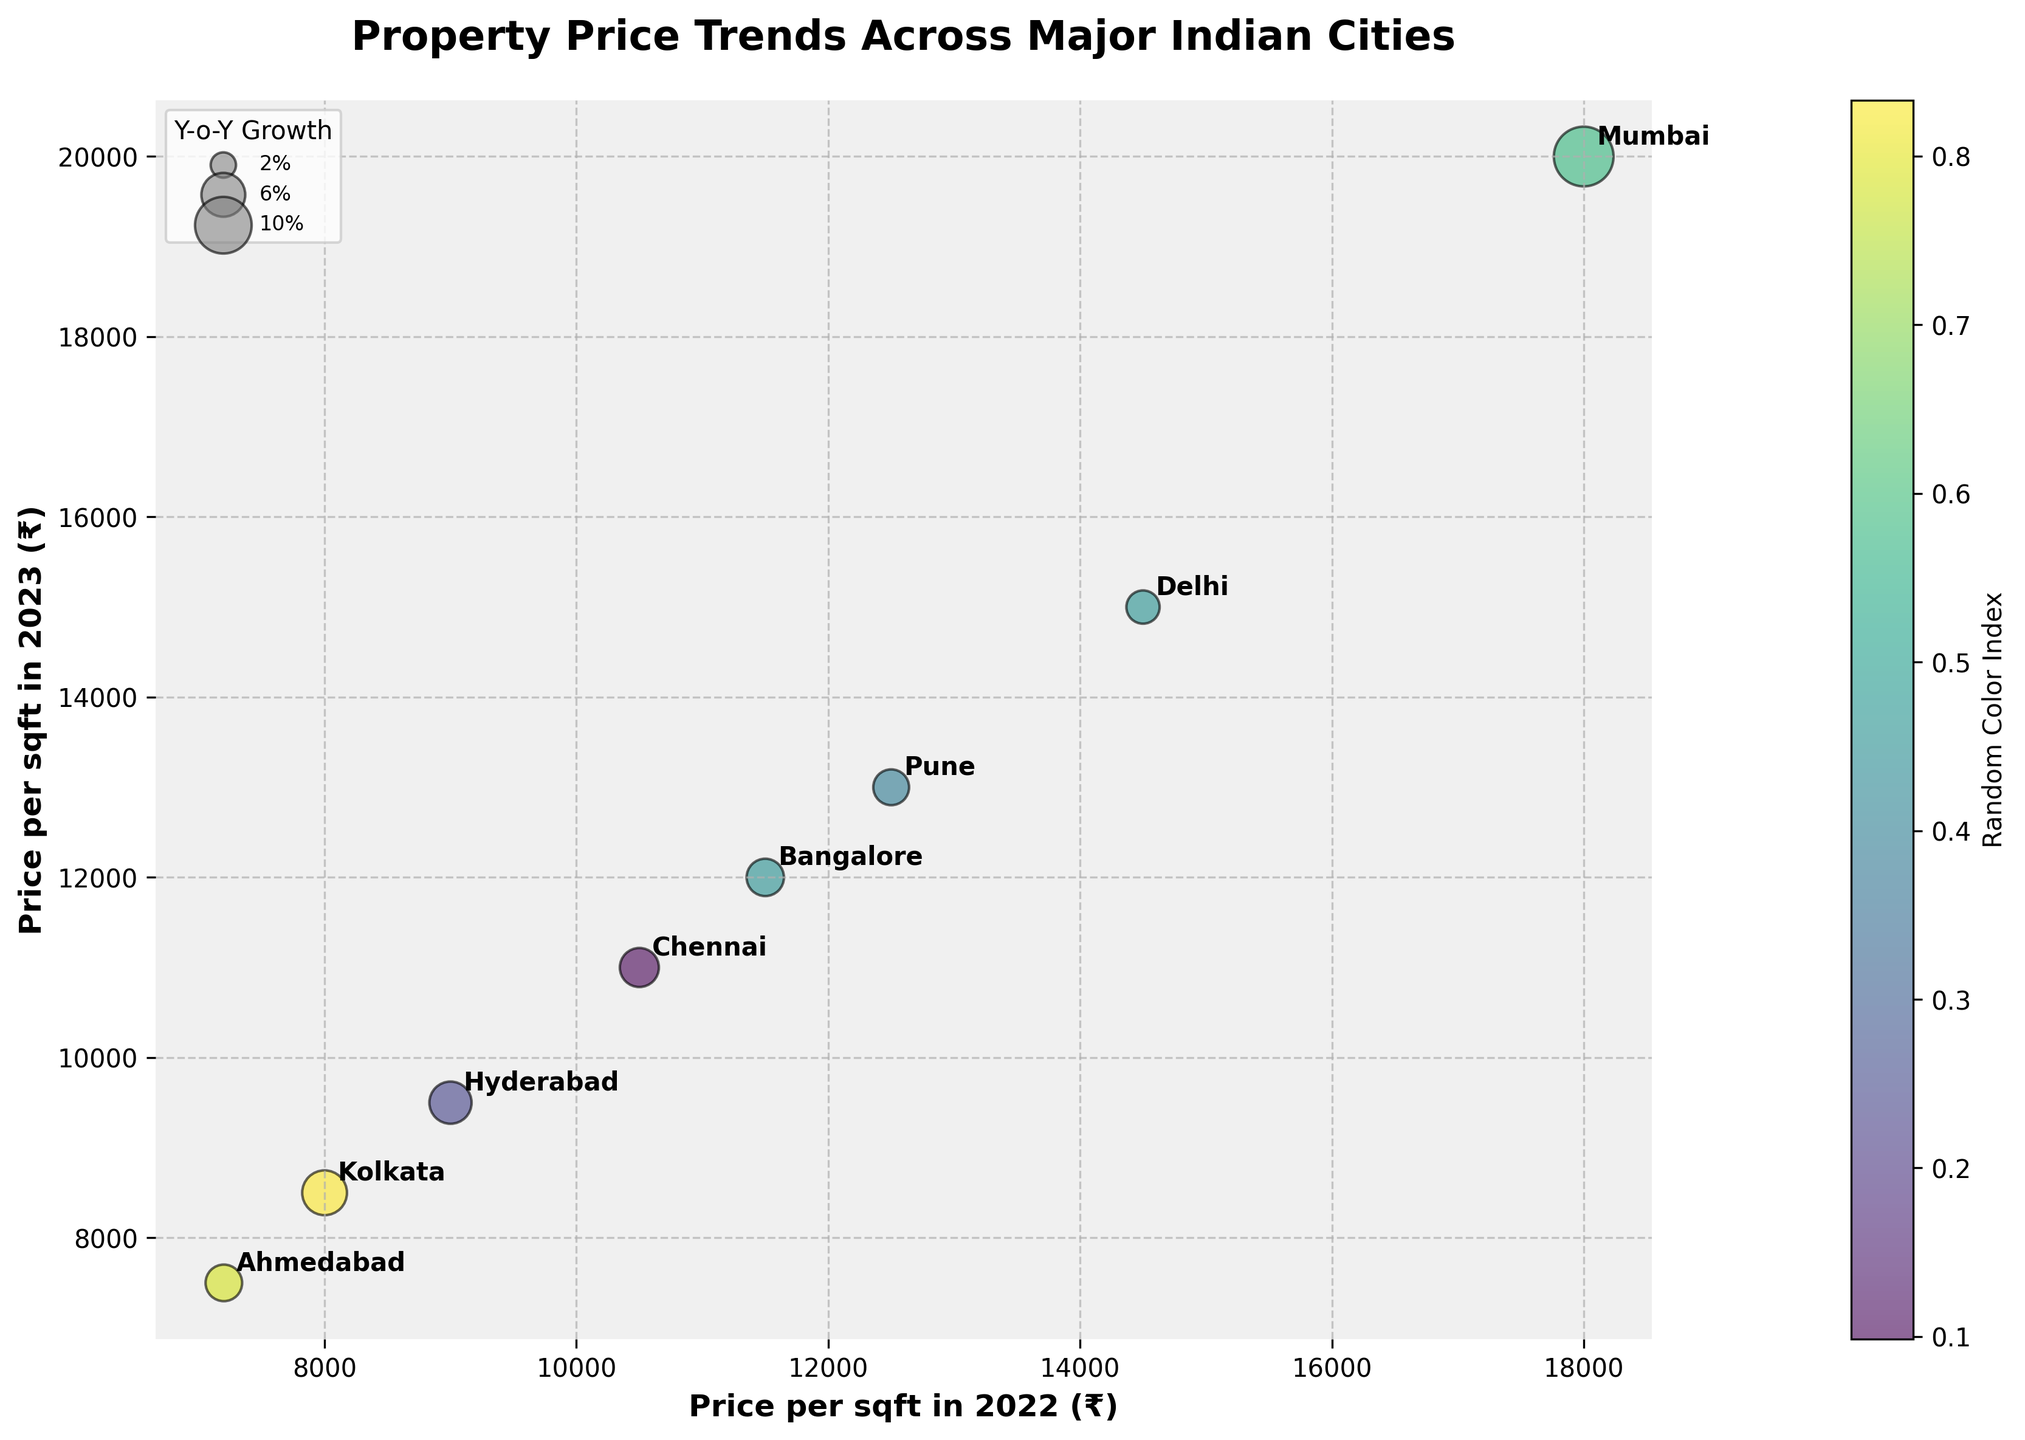what are the cities listed in the figure? The cities are annotated on the bubble chart. By reading the annotations, we can see the cities listed: Mumbai, Delhi, Bangalore, Hyderabad, Chennai, Pune, Kolkata, and Ahmedabad.
Answer: Mumbai, Delhi, Bangalore, Hyderabad, Chennai, Pune, Kolkata, Ahmedabad what is the title of the figure? The title of the figure is prominently displayed at the top of the chart. It reads "Property Price Trends Across Major Indian Cities".
Answer: Property Price Trends Across Major Indian Cities which city has the highest property price per square foot in 2023? By looking at the y-axis and identifying the highest point, we see Mumbai's bubble at ₹20000 per sqft.
Answer: Mumbai which city experienced the highest year-on-year growth percentage? The largest bubble size indicates the highest growth percentage. By comparing the sizes, Mumbai's bubble is the largest, indicating the highest Y-o-Y growth.
Answer: Mumbai compare the property prices of Delhi and Chennai in 2022. which was higher? By locating both Delhi and Chennai on the x-axis, we see Delhi's value at ₹14500, which is higher than Chennai's value of ₹10500.
Answer: Delhi which economic policy change is associated with Pune? The city bubbles are annotated with city names. By locating Pune, we see it is associated with "Residential Incentives".
Answer: Residential Incentives what's the average year-on-year growth percentage of Mumbai and Bangalore? Mumbai has 11.11% and Bangalore has 4.35%. The average is (11.11 + 4.35) / 2 = 7.73%.
Answer: 7.73% which city has a lower property price per square foot in 2023: Hyderabad or Kolkata? By locating both Hyderabad and Kolkata on the y-axis, we see that Kolkata has ₹8500, which is lower than Hyderabad's ₹9500.
Answer: Kolkata which two cities have relatively similar property prices in both 2022 and 2023? By looking for bubbles that are closely positioned on both axes, Chennai and Pune have similar property prices in both years (₹11000 vs ₹10500 for Chennai and ₹13000 vs ₹12500 for Pune).
Answer: Chennai and Pune how does the property price trend correlate with economic policy changes? Observing the chart, cities with significant economic policy changes (e.g., Mumbai with Stamp Duty Reduction and Hyderabad with IT Hubs Expansion) show considerable growth in property prices, suggesting a positive correlation.
Answer: Positive correlation 